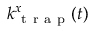Convert formula to latex. <formula><loc_0><loc_0><loc_500><loc_500>k _ { t r a p } ^ { x } ( t )</formula> 